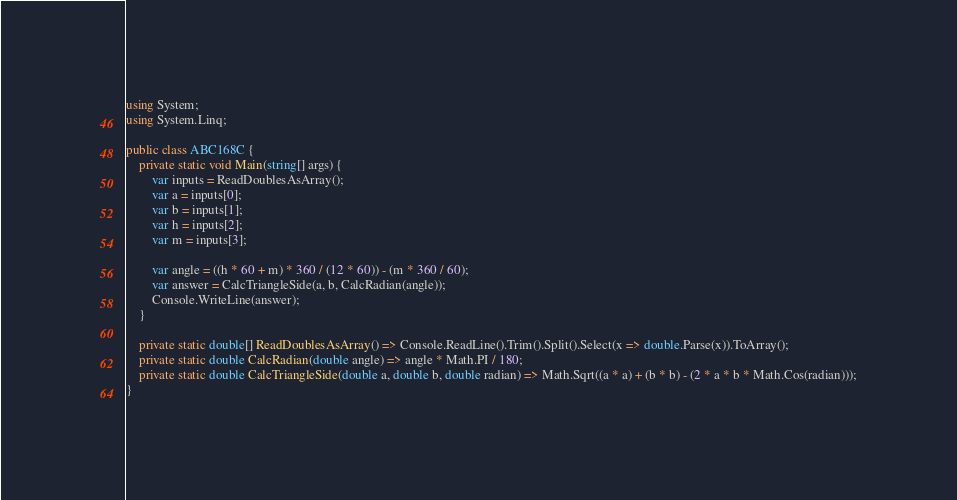<code> <loc_0><loc_0><loc_500><loc_500><_C#_>using System;
using System.Linq;

public class ABC168C {
	private static void Main(string[] args) {
		var inputs = ReadDoublesAsArray();
		var a = inputs[0];
		var b = inputs[1];
		var h = inputs[2];
		var m = inputs[3];

		var angle = ((h * 60 + m) * 360 / (12 * 60)) - (m * 360 / 60);
		var answer = CalcTriangleSide(a, b, CalcRadian(angle));
		Console.WriteLine(answer);
	}

	private static double[] ReadDoublesAsArray() => Console.ReadLine().Trim().Split().Select(x => double.Parse(x)).ToArray();
	private static double CalcRadian(double angle) => angle * Math.PI / 180;
	private static double CalcTriangleSide(double a, double b, double radian) => Math.Sqrt((a * a) + (b * b) - (2 * a * b * Math.Cos(radian)));
}</code> 